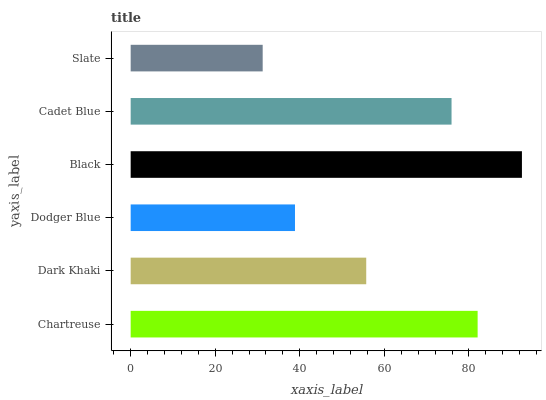Is Slate the minimum?
Answer yes or no. Yes. Is Black the maximum?
Answer yes or no. Yes. Is Dark Khaki the minimum?
Answer yes or no. No. Is Dark Khaki the maximum?
Answer yes or no. No. Is Chartreuse greater than Dark Khaki?
Answer yes or no. Yes. Is Dark Khaki less than Chartreuse?
Answer yes or no. Yes. Is Dark Khaki greater than Chartreuse?
Answer yes or no. No. Is Chartreuse less than Dark Khaki?
Answer yes or no. No. Is Cadet Blue the high median?
Answer yes or no. Yes. Is Dark Khaki the low median?
Answer yes or no. Yes. Is Dark Khaki the high median?
Answer yes or no. No. Is Black the low median?
Answer yes or no. No. 